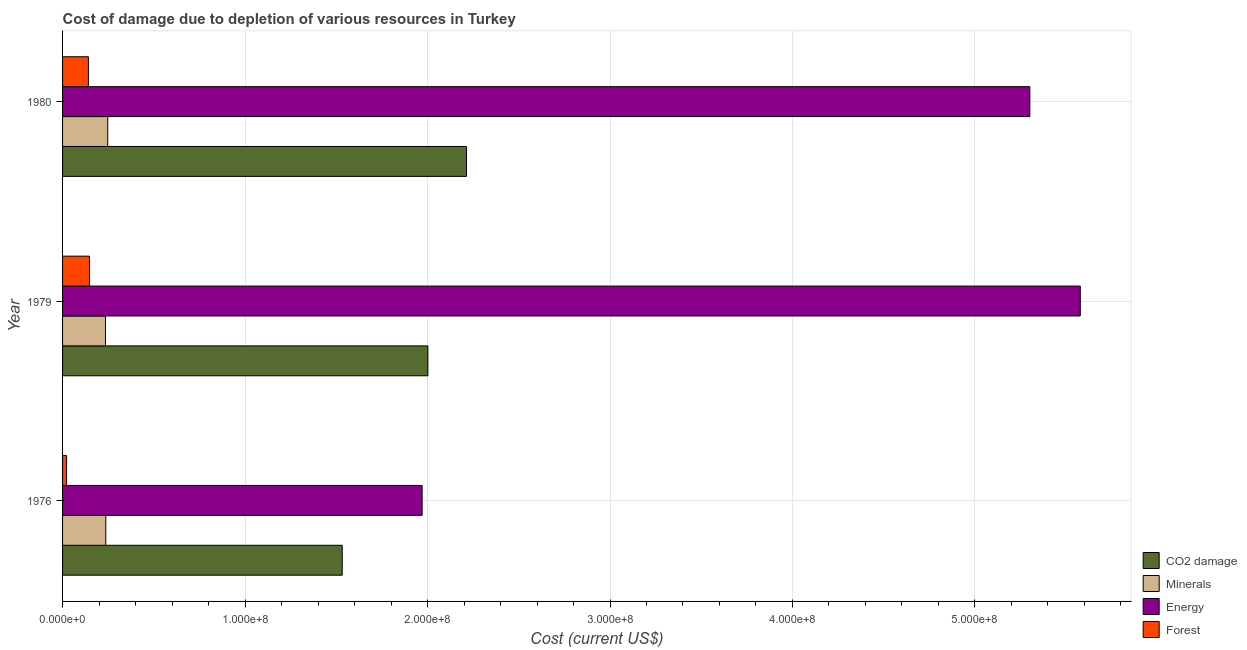How many different coloured bars are there?
Your response must be concise. 4. Are the number of bars per tick equal to the number of legend labels?
Provide a succinct answer. Yes. Are the number of bars on each tick of the Y-axis equal?
Provide a succinct answer. Yes. How many bars are there on the 2nd tick from the top?
Your answer should be compact. 4. What is the label of the 2nd group of bars from the top?
Provide a succinct answer. 1979. What is the cost of damage due to depletion of minerals in 1980?
Ensure brevity in your answer.  2.48e+07. Across all years, what is the maximum cost of damage due to depletion of forests?
Your answer should be compact. 1.48e+07. Across all years, what is the minimum cost of damage due to depletion of forests?
Give a very brief answer. 2.21e+06. In which year was the cost of damage due to depletion of coal minimum?
Provide a succinct answer. 1976. What is the total cost of damage due to depletion of coal in the graph?
Make the answer very short. 5.75e+08. What is the difference between the cost of damage due to depletion of minerals in 1976 and that in 1979?
Keep it short and to the point. 1.84e+05. What is the difference between the cost of damage due to depletion of minerals in 1980 and the cost of damage due to depletion of coal in 1976?
Your answer should be very brief. -1.29e+08. What is the average cost of damage due to depletion of minerals per year?
Keep it short and to the point. 2.40e+07. In the year 1976, what is the difference between the cost of damage due to depletion of coal and cost of damage due to depletion of minerals?
Provide a succinct answer. 1.30e+08. In how many years, is the cost of damage due to depletion of minerals greater than 160000000 US$?
Your answer should be compact. 0. What is the ratio of the cost of damage due to depletion of minerals in 1976 to that in 1979?
Provide a succinct answer. 1.01. Is the cost of damage due to depletion of forests in 1976 less than that in 1979?
Keep it short and to the point. Yes. Is the difference between the cost of damage due to depletion of minerals in 1976 and 1980 greater than the difference between the cost of damage due to depletion of forests in 1976 and 1980?
Your answer should be compact. Yes. What is the difference between the highest and the second highest cost of damage due to depletion of coal?
Make the answer very short. 2.12e+07. What is the difference between the highest and the lowest cost of damage due to depletion of minerals?
Keep it short and to the point. 1.24e+06. Is the sum of the cost of damage due to depletion of forests in 1976 and 1979 greater than the maximum cost of damage due to depletion of coal across all years?
Keep it short and to the point. No. What does the 2nd bar from the top in 1976 represents?
Give a very brief answer. Energy. What does the 4th bar from the bottom in 1976 represents?
Provide a short and direct response. Forest. How many bars are there?
Your response must be concise. 12. What is the difference between two consecutive major ticks on the X-axis?
Offer a very short reply. 1.00e+08. Does the graph contain grids?
Your response must be concise. Yes. Where does the legend appear in the graph?
Provide a succinct answer. Bottom right. How are the legend labels stacked?
Offer a terse response. Vertical. What is the title of the graph?
Provide a short and direct response. Cost of damage due to depletion of various resources in Turkey . Does "Insurance services" appear as one of the legend labels in the graph?
Give a very brief answer. No. What is the label or title of the X-axis?
Your answer should be compact. Cost (current US$). What is the label or title of the Y-axis?
Your response must be concise. Year. What is the Cost (current US$) in CO2 damage in 1976?
Your answer should be very brief. 1.53e+08. What is the Cost (current US$) of Minerals in 1976?
Keep it short and to the point. 2.37e+07. What is the Cost (current US$) in Energy in 1976?
Your response must be concise. 1.97e+08. What is the Cost (current US$) in Forest in 1976?
Make the answer very short. 2.21e+06. What is the Cost (current US$) in CO2 damage in 1979?
Provide a succinct answer. 2.00e+08. What is the Cost (current US$) of Minerals in 1979?
Your answer should be compact. 2.35e+07. What is the Cost (current US$) in Energy in 1979?
Keep it short and to the point. 5.58e+08. What is the Cost (current US$) of Forest in 1979?
Provide a short and direct response. 1.48e+07. What is the Cost (current US$) of CO2 damage in 1980?
Give a very brief answer. 2.21e+08. What is the Cost (current US$) of Minerals in 1980?
Ensure brevity in your answer.  2.48e+07. What is the Cost (current US$) of Energy in 1980?
Provide a succinct answer. 5.30e+08. What is the Cost (current US$) of Forest in 1980?
Your response must be concise. 1.42e+07. Across all years, what is the maximum Cost (current US$) in CO2 damage?
Your response must be concise. 2.21e+08. Across all years, what is the maximum Cost (current US$) of Minerals?
Your response must be concise. 2.48e+07. Across all years, what is the maximum Cost (current US$) in Energy?
Your answer should be very brief. 5.58e+08. Across all years, what is the maximum Cost (current US$) in Forest?
Ensure brevity in your answer.  1.48e+07. Across all years, what is the minimum Cost (current US$) of CO2 damage?
Keep it short and to the point. 1.53e+08. Across all years, what is the minimum Cost (current US$) of Minerals?
Your answer should be compact. 2.35e+07. Across all years, what is the minimum Cost (current US$) of Energy?
Offer a very short reply. 1.97e+08. Across all years, what is the minimum Cost (current US$) of Forest?
Give a very brief answer. 2.21e+06. What is the total Cost (current US$) in CO2 damage in the graph?
Keep it short and to the point. 5.75e+08. What is the total Cost (current US$) in Minerals in the graph?
Your answer should be very brief. 7.20e+07. What is the total Cost (current US$) in Energy in the graph?
Give a very brief answer. 1.28e+09. What is the total Cost (current US$) of Forest in the graph?
Ensure brevity in your answer.  3.11e+07. What is the difference between the Cost (current US$) of CO2 damage in 1976 and that in 1979?
Ensure brevity in your answer.  -4.70e+07. What is the difference between the Cost (current US$) of Minerals in 1976 and that in 1979?
Provide a short and direct response. 1.84e+05. What is the difference between the Cost (current US$) in Energy in 1976 and that in 1979?
Your answer should be very brief. -3.61e+08. What is the difference between the Cost (current US$) in Forest in 1976 and that in 1979?
Keep it short and to the point. -1.26e+07. What is the difference between the Cost (current US$) of CO2 damage in 1976 and that in 1980?
Offer a terse response. -6.81e+07. What is the difference between the Cost (current US$) of Minerals in 1976 and that in 1980?
Make the answer very short. -1.05e+06. What is the difference between the Cost (current US$) of Energy in 1976 and that in 1980?
Give a very brief answer. -3.33e+08. What is the difference between the Cost (current US$) in Forest in 1976 and that in 1980?
Offer a terse response. -1.20e+07. What is the difference between the Cost (current US$) of CO2 damage in 1979 and that in 1980?
Your answer should be compact. -2.12e+07. What is the difference between the Cost (current US$) of Minerals in 1979 and that in 1980?
Keep it short and to the point. -1.24e+06. What is the difference between the Cost (current US$) of Energy in 1979 and that in 1980?
Make the answer very short. 2.77e+07. What is the difference between the Cost (current US$) of Forest in 1979 and that in 1980?
Provide a succinct answer. 6.06e+05. What is the difference between the Cost (current US$) in CO2 damage in 1976 and the Cost (current US$) in Minerals in 1979?
Offer a very short reply. 1.30e+08. What is the difference between the Cost (current US$) of CO2 damage in 1976 and the Cost (current US$) of Energy in 1979?
Provide a succinct answer. -4.04e+08. What is the difference between the Cost (current US$) in CO2 damage in 1976 and the Cost (current US$) in Forest in 1979?
Offer a very short reply. 1.38e+08. What is the difference between the Cost (current US$) of Minerals in 1976 and the Cost (current US$) of Energy in 1979?
Give a very brief answer. -5.34e+08. What is the difference between the Cost (current US$) of Minerals in 1976 and the Cost (current US$) of Forest in 1979?
Provide a short and direct response. 8.93e+06. What is the difference between the Cost (current US$) of Energy in 1976 and the Cost (current US$) of Forest in 1979?
Offer a very short reply. 1.82e+08. What is the difference between the Cost (current US$) of CO2 damage in 1976 and the Cost (current US$) of Minerals in 1980?
Keep it short and to the point. 1.29e+08. What is the difference between the Cost (current US$) of CO2 damage in 1976 and the Cost (current US$) of Energy in 1980?
Offer a terse response. -3.77e+08. What is the difference between the Cost (current US$) of CO2 damage in 1976 and the Cost (current US$) of Forest in 1980?
Your answer should be compact. 1.39e+08. What is the difference between the Cost (current US$) in Minerals in 1976 and the Cost (current US$) in Energy in 1980?
Offer a terse response. -5.06e+08. What is the difference between the Cost (current US$) in Minerals in 1976 and the Cost (current US$) in Forest in 1980?
Provide a short and direct response. 9.54e+06. What is the difference between the Cost (current US$) in Energy in 1976 and the Cost (current US$) in Forest in 1980?
Your answer should be very brief. 1.83e+08. What is the difference between the Cost (current US$) of CO2 damage in 1979 and the Cost (current US$) of Minerals in 1980?
Your response must be concise. 1.75e+08. What is the difference between the Cost (current US$) in CO2 damage in 1979 and the Cost (current US$) in Energy in 1980?
Make the answer very short. -3.30e+08. What is the difference between the Cost (current US$) of CO2 damage in 1979 and the Cost (current US$) of Forest in 1980?
Offer a very short reply. 1.86e+08. What is the difference between the Cost (current US$) of Minerals in 1979 and the Cost (current US$) of Energy in 1980?
Provide a short and direct response. -5.07e+08. What is the difference between the Cost (current US$) of Minerals in 1979 and the Cost (current US$) of Forest in 1980?
Offer a terse response. 9.36e+06. What is the difference between the Cost (current US$) in Energy in 1979 and the Cost (current US$) in Forest in 1980?
Give a very brief answer. 5.44e+08. What is the average Cost (current US$) in CO2 damage per year?
Provide a short and direct response. 1.92e+08. What is the average Cost (current US$) of Minerals per year?
Make the answer very short. 2.40e+07. What is the average Cost (current US$) in Energy per year?
Your answer should be very brief. 4.28e+08. What is the average Cost (current US$) of Forest per year?
Make the answer very short. 1.04e+07. In the year 1976, what is the difference between the Cost (current US$) in CO2 damage and Cost (current US$) in Minerals?
Your answer should be compact. 1.30e+08. In the year 1976, what is the difference between the Cost (current US$) in CO2 damage and Cost (current US$) in Energy?
Your response must be concise. -4.38e+07. In the year 1976, what is the difference between the Cost (current US$) in CO2 damage and Cost (current US$) in Forest?
Give a very brief answer. 1.51e+08. In the year 1976, what is the difference between the Cost (current US$) in Minerals and Cost (current US$) in Energy?
Make the answer very short. -1.73e+08. In the year 1976, what is the difference between the Cost (current US$) in Minerals and Cost (current US$) in Forest?
Provide a succinct answer. 2.15e+07. In the year 1976, what is the difference between the Cost (current US$) of Energy and Cost (current US$) of Forest?
Ensure brevity in your answer.  1.95e+08. In the year 1979, what is the difference between the Cost (current US$) in CO2 damage and Cost (current US$) in Minerals?
Your answer should be compact. 1.77e+08. In the year 1979, what is the difference between the Cost (current US$) of CO2 damage and Cost (current US$) of Energy?
Make the answer very short. -3.58e+08. In the year 1979, what is the difference between the Cost (current US$) in CO2 damage and Cost (current US$) in Forest?
Provide a succinct answer. 1.85e+08. In the year 1979, what is the difference between the Cost (current US$) in Minerals and Cost (current US$) in Energy?
Offer a terse response. -5.34e+08. In the year 1979, what is the difference between the Cost (current US$) of Minerals and Cost (current US$) of Forest?
Offer a terse response. 8.75e+06. In the year 1979, what is the difference between the Cost (current US$) of Energy and Cost (current US$) of Forest?
Offer a terse response. 5.43e+08. In the year 1980, what is the difference between the Cost (current US$) in CO2 damage and Cost (current US$) in Minerals?
Your answer should be compact. 1.97e+08. In the year 1980, what is the difference between the Cost (current US$) in CO2 damage and Cost (current US$) in Energy?
Provide a short and direct response. -3.09e+08. In the year 1980, what is the difference between the Cost (current US$) of CO2 damage and Cost (current US$) of Forest?
Keep it short and to the point. 2.07e+08. In the year 1980, what is the difference between the Cost (current US$) in Minerals and Cost (current US$) in Energy?
Provide a short and direct response. -5.05e+08. In the year 1980, what is the difference between the Cost (current US$) in Minerals and Cost (current US$) in Forest?
Your response must be concise. 1.06e+07. In the year 1980, what is the difference between the Cost (current US$) of Energy and Cost (current US$) of Forest?
Give a very brief answer. 5.16e+08. What is the ratio of the Cost (current US$) of CO2 damage in 1976 to that in 1979?
Ensure brevity in your answer.  0.77. What is the ratio of the Cost (current US$) in Energy in 1976 to that in 1979?
Your answer should be compact. 0.35. What is the ratio of the Cost (current US$) in Forest in 1976 to that in 1979?
Your response must be concise. 0.15. What is the ratio of the Cost (current US$) of CO2 damage in 1976 to that in 1980?
Provide a succinct answer. 0.69. What is the ratio of the Cost (current US$) in Minerals in 1976 to that in 1980?
Ensure brevity in your answer.  0.96. What is the ratio of the Cost (current US$) in Energy in 1976 to that in 1980?
Make the answer very short. 0.37. What is the ratio of the Cost (current US$) of Forest in 1976 to that in 1980?
Your response must be concise. 0.16. What is the ratio of the Cost (current US$) of CO2 damage in 1979 to that in 1980?
Provide a short and direct response. 0.9. What is the ratio of the Cost (current US$) of Minerals in 1979 to that in 1980?
Give a very brief answer. 0.95. What is the ratio of the Cost (current US$) in Energy in 1979 to that in 1980?
Provide a succinct answer. 1.05. What is the ratio of the Cost (current US$) of Forest in 1979 to that in 1980?
Your response must be concise. 1.04. What is the difference between the highest and the second highest Cost (current US$) of CO2 damage?
Give a very brief answer. 2.12e+07. What is the difference between the highest and the second highest Cost (current US$) in Minerals?
Offer a terse response. 1.05e+06. What is the difference between the highest and the second highest Cost (current US$) in Energy?
Keep it short and to the point. 2.77e+07. What is the difference between the highest and the second highest Cost (current US$) of Forest?
Offer a terse response. 6.06e+05. What is the difference between the highest and the lowest Cost (current US$) in CO2 damage?
Give a very brief answer. 6.81e+07. What is the difference between the highest and the lowest Cost (current US$) of Minerals?
Your answer should be compact. 1.24e+06. What is the difference between the highest and the lowest Cost (current US$) of Energy?
Your response must be concise. 3.61e+08. What is the difference between the highest and the lowest Cost (current US$) in Forest?
Your answer should be very brief. 1.26e+07. 